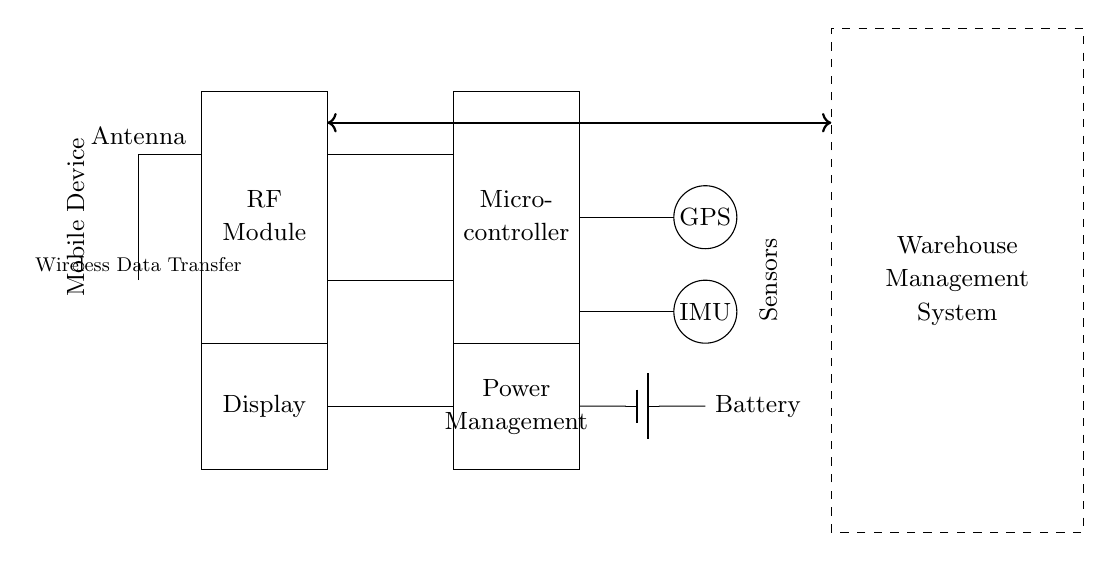What component is responsible for wireless data transfer? The thick arrow labeled "Wireless Data Transfer" indicates the primary component used for wireless communication, which connects the RF Module in the mobile device to the Warehouse Management System.
Answer: Wireless Data Transfer What type of sensors are included in the circuit? The diagram displays two types of sensors, GPS and IMU, represented as circles. Each sensor is explicitly labeled within the circuit.
Answer: GPS, IMU How many main components are there in the mobile device? The circuit diagram has five main components: Antenna, RF Module, Microcontroller, Power Management, and Display. Counting these components yields a total of five.
Answer: Five What is the function of the Microcontroller in this setup? The Microcontroller processes data from various inputs and coordinates the data transfer to the Warehouse Management System, making it essential for the operation of the mobile device.
Answer: Data processing What is the purpose of the Power Management block? This block regulates and manages the electrical power supplied to the mobile device, ensuring each component receives the appropriate voltage for optimal functioning.
Answer: Power regulation How is the Battery connected in this circuit? The battery is connected to the Power Management block, which then distributes power to the other components within the circuit, demonstrating how it supplies energy to the entire system.
Answer: To Power Management 